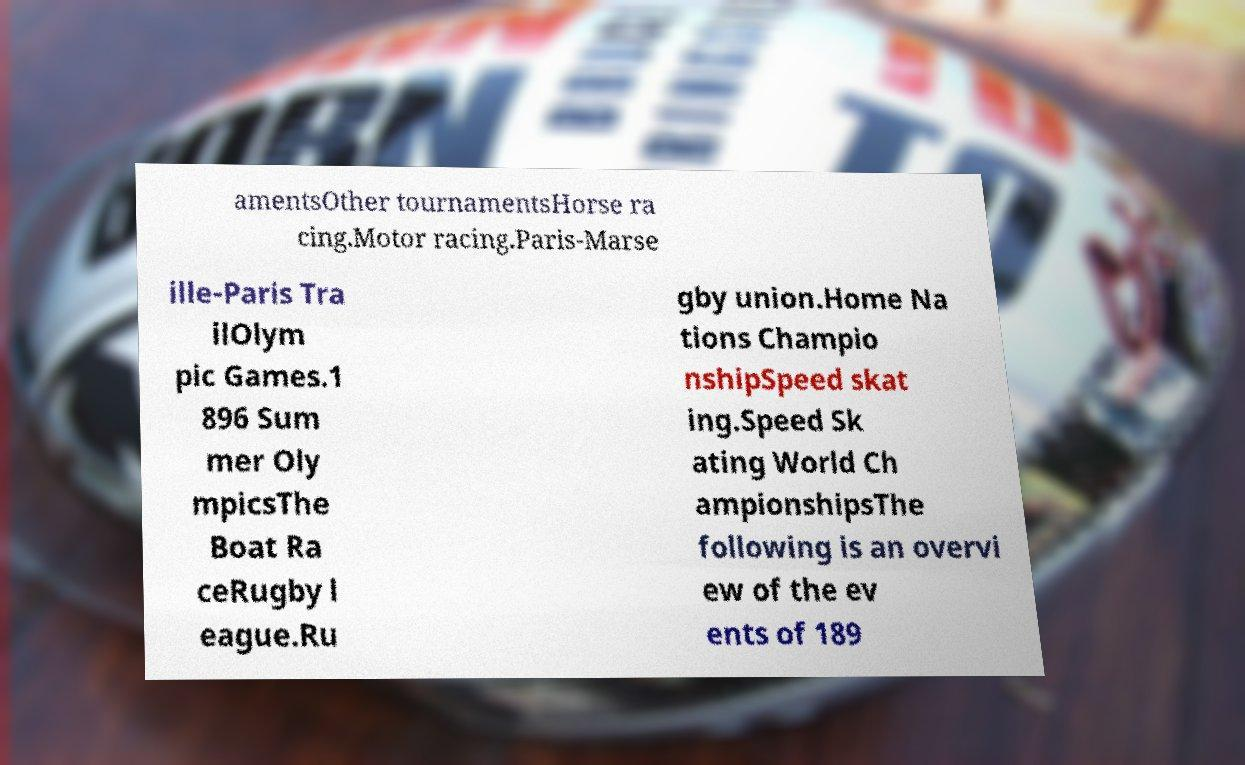Could you extract and type out the text from this image? amentsOther tournamentsHorse ra cing.Motor racing.Paris-Marse ille-Paris Tra ilOlym pic Games.1 896 Sum mer Oly mpicsThe Boat Ra ceRugby l eague.Ru gby union.Home Na tions Champio nshipSpeed skat ing.Speed Sk ating World Ch ampionshipsThe following is an overvi ew of the ev ents of 189 